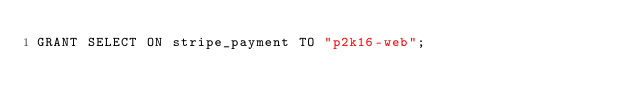<code> <loc_0><loc_0><loc_500><loc_500><_SQL_>GRANT SELECT ON stripe_payment TO "p2k16-web";
</code> 